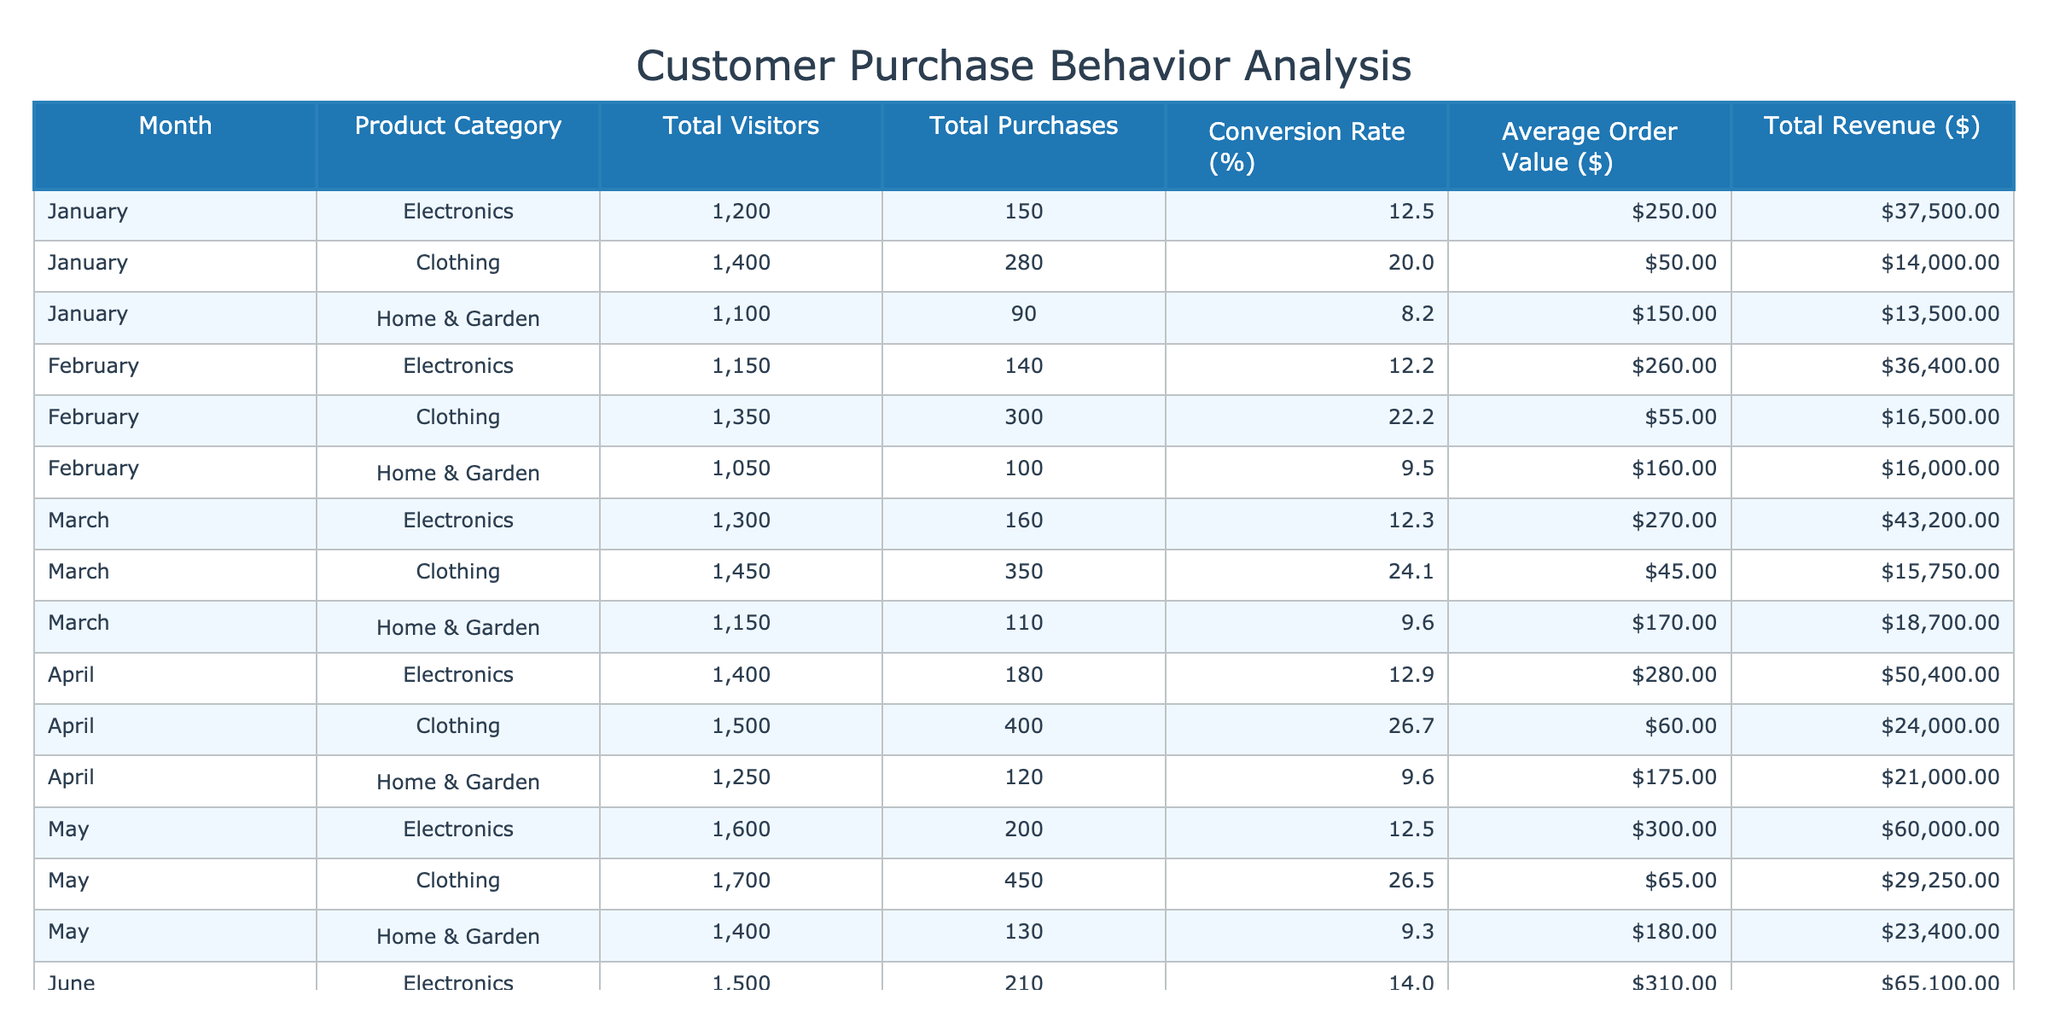What was the conversion rate for Clothing in April? The conversion rate for Clothing in April is listed in the table under the 'Conversion Rate (%)' column for the corresponding month and category. It shows a value of 26.7%.
Answer: 26.7 What category had the highest total purchases in March? In March, the Clothing category had the highest total purchases with a count of 350, as compared to 160 for Electronics and 110 for Home & Garden.
Answer: Clothing What was the total revenue generated from Home & Garden products in February? The total revenue from the Home & Garden category in February can be found in the 'Total Revenue ($)' column next to February and Home & Garden, which shows a value of 16,000.
Answer: 16000 What is the difference in average order value between Electronics and Home & Garden in May? For May, the average order value for Electronics is 300, and for Home & Garden, it is 180. The difference is calculated as 300 - 180 = 120.
Answer: 120 Was the conversion rate for Electronics in June higher than in January? In June, the conversion rate for Electronics is 14.0%, while in January, it is 12.5%. Since 14.0% is greater than 12.5%, the answer is yes.
Answer: Yes What is the average conversion rate for Clothing across all months? The conversion rates for Clothing are: 20.0% (January), 22.2% (February), 24.1% (March), 26.7% (April), 26.5% (May), and 31.3% (June). To find the average, we sum these rates (20.0 + 22.2 + 24.1 + 26.7 + 26.5 + 31.3 = 150.8) and divide by 6, which gives us an average of approximately 25.13%.
Answer: 25.13 Which month had the highest total visitors across all product categories? Total visitors for each month are as follows: January - 1200 + 1400 + 1100 = 3700, February - 1150 + 1350 + 1050 = 3550, March - 1300 + 1450 + 1150 = 3900, April - 1400 + 1500 + 1250 = 4150, May - 1600 + 1700 + 1400 = 4700, June - 1500 + 1600 + 1300 = 4400. May has the highest total visitors with 4700.
Answer: May What was the total number of purchases for the Electronics category over all months? To find the total purchases for the Electronics category, we sum the purchases from each month: 150 (January) + 140 (February) + 160 (March) + 180 (April) + 200 (May) + 210 (June) = 1,040 purchases in total.
Answer: 1040 How many product categories had a conversion rate above 20% in June? In June, the conversion rates for the categories are 14.0% (Electronics), 31.3% (Clothing), and 10.8% (Home & Garden). Only Clothing has a conversion rate above 20%, thus there is 1 category exceeding that rate.
Answer: 1 